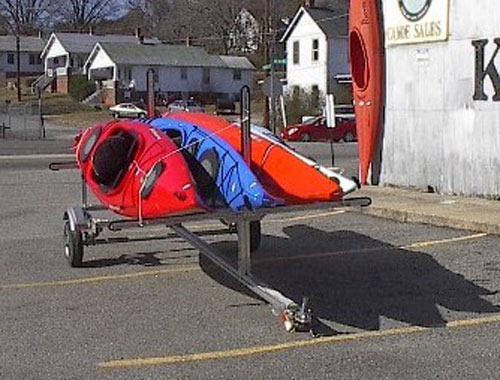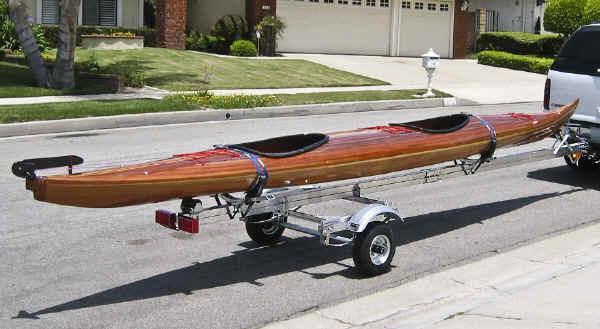The first image is the image on the left, the second image is the image on the right. Assess this claim about the two images: "An image shows an unattached trailer loaded with only two canoes.". Correct or not? Answer yes or no. No. The first image is the image on the left, the second image is the image on the right. Assess this claim about the two images: "One of the trailers is rectangular in shape.". Correct or not? Answer yes or no. No. 